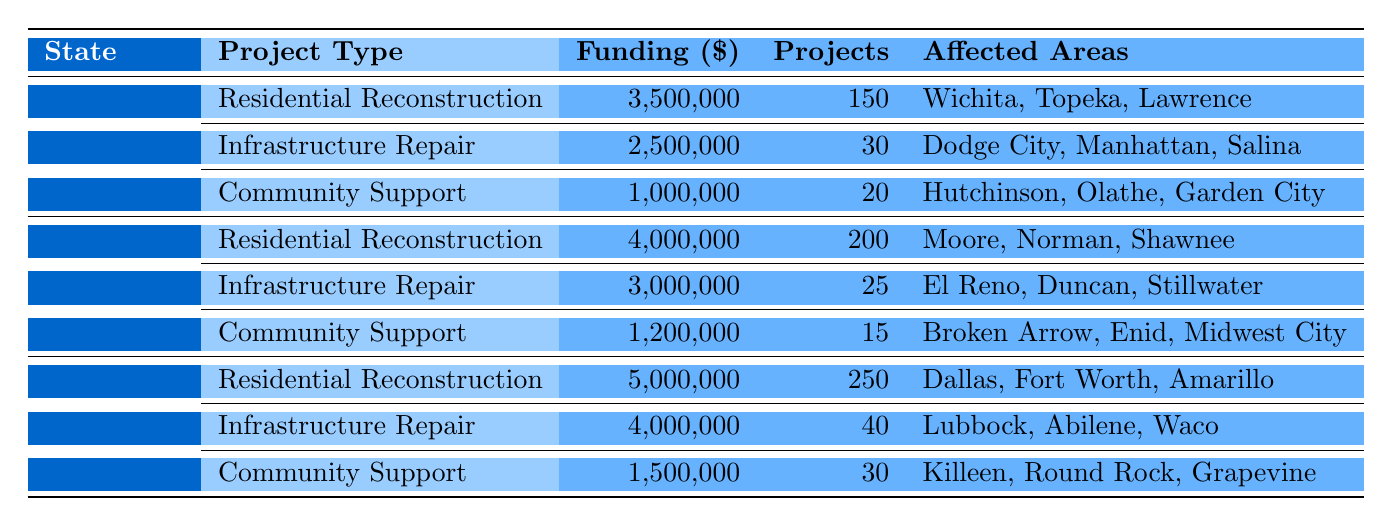What is the total funding allocated for Residential Reconstruction in Texas? To find the total funding for Residential Reconstruction in Texas, we look at the table entry for Texas under this project type, which shows a funding amount of 5,000,000 dollars.
Answer: 5,000,000 How many projects are funded for Community Support in Kansas? The table indicates that Kansas has allocated funding for 20 Community Support projects.
Answer: 20 Which state has the highest funding amount allocated for Infrastructure Repair? By comparing the funding amounts for Infrastructure Repair across all states, we find that Texas has the highest with 4,000,000 dollars, while Kansas has 2,500,000 and Oklahoma has 3,000,000.
Answer: Texas What is the average number of projects funded for Community Support across all states? We sum the number of Community Support projects for each state: Kansas (20) + Oklahoma (15) + Texas (30) = 65. Then, we divide by the number of states, which is 3: 65/3 = approximately 21.67.
Answer: 21.67 Is the total funding for Residential Reconstruction in Oklahoma greater than the total funding for Community Support in Texas? We compare the funding amounts: Residential Reconstruction in Oklahoma is 4,000,000 dollars, while Community Support in Texas is 1,500,000 dollars. Since 4,000,000 is greater than 1,500,000, the statement is true.
Answer: Yes What is the total funding allocation for Infrastructure Repair in both Oklahoma and Kansas? We add the funding amounts for Infrastructure Repair in both Oklahoma (3,000,000) and Kansas (2,500,000): 3,000,000 + 2,500,000 = 5,500,000.
Answer: 5,500,000 Which area received the least funding for Community Support, and what is the amount? By examining Community Support funding in each state: Kansas has 1,000,000, Oklahoma has 1,200,000, and Texas has 1,500,000. The least amount is from Kansas at 1,000,000 dollars.
Answer: Kansas, 1,000,000 How many projects are funded for Infrastructure Repair in Oklahoma compared to Kansas? The number of Infrastructure Repair projects in Oklahoma is 25, while in Kansas it is 30. Since 25 is less than 30, Kansas has more projects funded for this type.
Answer: Kansas has more projects What is the total number of projects funded across all states? We sum the project counts for Residential Reconstruction, Infrastructure Repair, and Community Support across all states: Kansas (150 + 30 + 20), Oklahoma (200 + 25 + 15), and Texas (250 + 40 + 30). The total is 150 + 30 + 20 + 200 + 25 + 15 + 250 + 40 + 30 = 740.
Answer: 740 